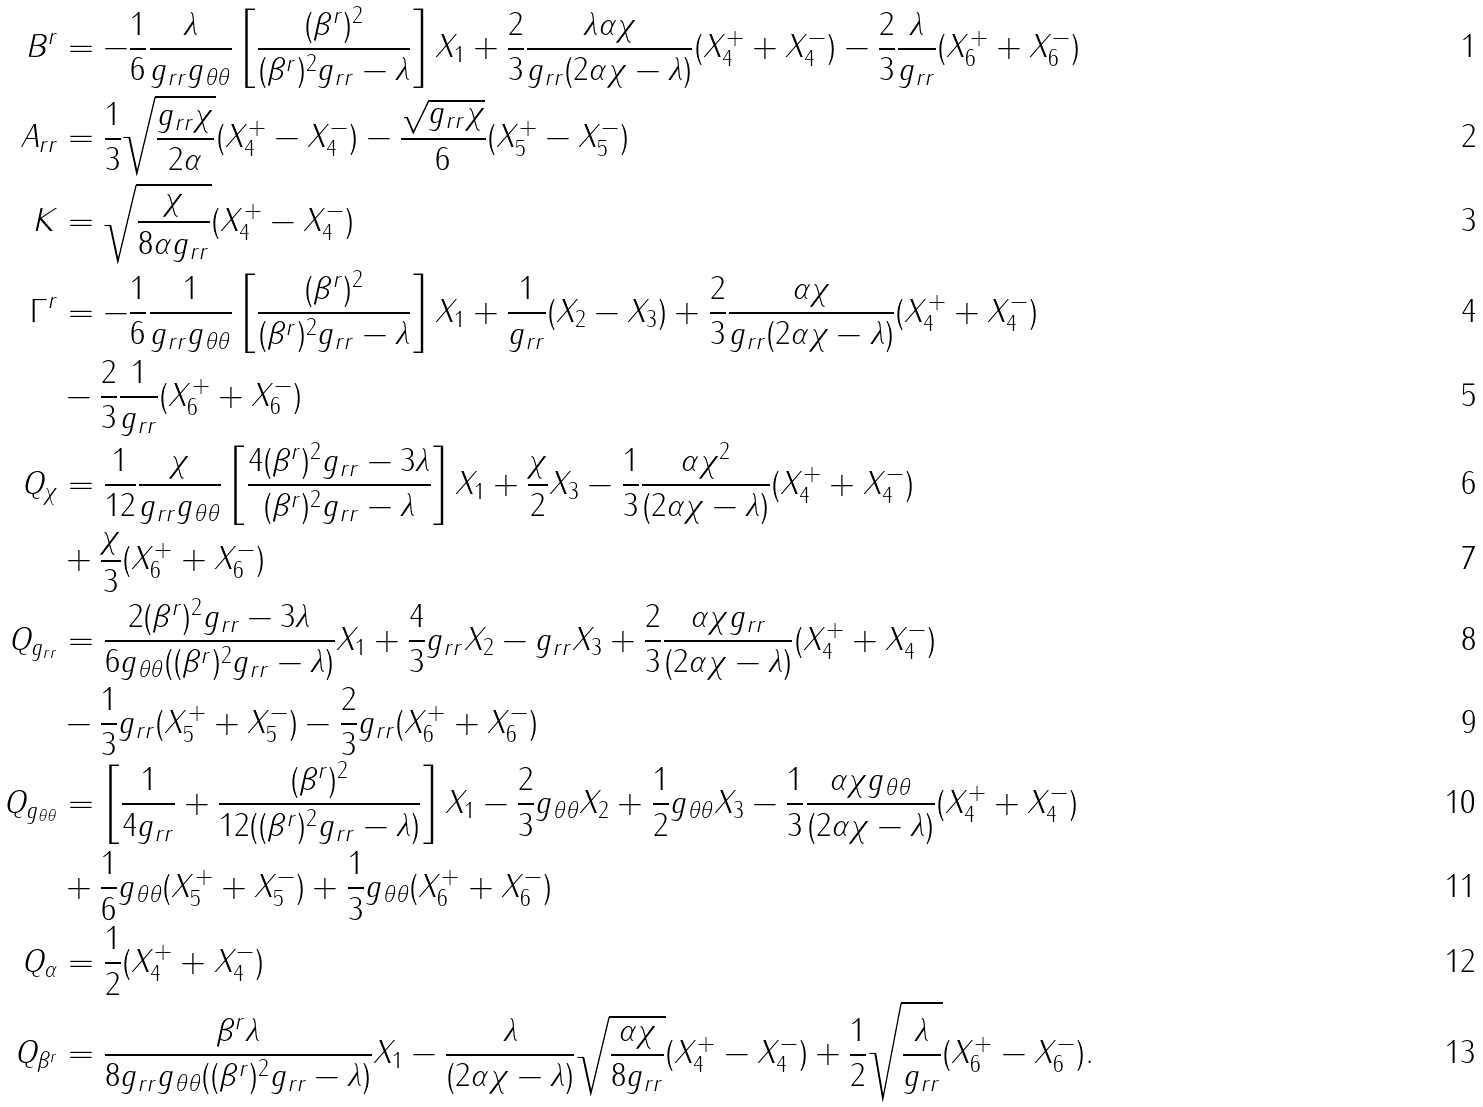Convert formula to latex. <formula><loc_0><loc_0><loc_500><loc_500>B ^ { r } & = - \frac { 1 } { 6 } \frac { \lambda } { g _ { r r } g _ { \theta \theta } } \left [ \frac { ( \beta ^ { r } ) ^ { 2 } } { ( \beta ^ { r } ) ^ { 2 } g _ { r r } - \lambda } \right ] X _ { 1 } + \frac { 2 } { 3 } \frac { \lambda \alpha \chi } { g _ { r r } ( 2 \alpha \chi - \lambda ) } ( X ^ { + } _ { 4 } + X ^ { - } _ { 4 } ) - \frac { 2 } { 3 } \frac { \lambda } { g _ { r r } } ( X ^ { + } _ { 6 } + X ^ { - } _ { 6 } ) \\ A _ { r r } & = \frac { 1 } { 3 } \sqrt { \frac { g _ { r r } \chi } { 2 \alpha } } ( X _ { 4 } ^ { + } - X _ { 4 } ^ { - } ) - \frac { \sqrt { g _ { r r } \chi } } { 6 } ( X _ { 5 } ^ { + } - X _ { 5 } ^ { - } ) \\ K & = \sqrt { \frac { \chi } { 8 \alpha g _ { r r } } } ( X _ { 4 } ^ { + } - X _ { 4 } ^ { - } ) \\ \Gamma ^ { r } & = - \frac { 1 } { 6 } \frac { 1 } { g _ { r r } g _ { \theta \theta } } \left [ \frac { ( \beta ^ { r } ) ^ { 2 } } { ( \beta ^ { r } ) ^ { 2 } g _ { r r } - \lambda } \right ] X _ { 1 } + \frac { 1 } { g _ { r r } } ( X _ { 2 } - X _ { 3 } ) + \frac { 2 } { 3 } \frac { \alpha \chi } { g _ { r r } ( 2 \alpha \chi - \lambda ) } ( X ^ { + } _ { 4 } + X ^ { - } _ { 4 } ) \\ & - \frac { 2 } { 3 } \frac { 1 } { g _ { r r } } ( X ^ { + } _ { 6 } + X ^ { - } _ { 6 } ) \\ Q _ { \chi } & = \frac { 1 } { 1 2 } \frac { \chi } { g _ { r r } g _ { \theta \theta } } \left [ \frac { 4 ( \beta ^ { r } ) ^ { 2 } g _ { r r } - 3 \lambda } { ( \beta ^ { r } ) ^ { 2 } g _ { r r } - \lambda } \right ] X _ { 1 } + \frac { \chi } { 2 } X _ { 3 } - \frac { 1 } { 3 } \frac { \alpha \chi ^ { 2 } } { ( 2 \alpha \chi - \lambda ) } ( X ^ { + } _ { 4 } + X ^ { - } _ { 4 } ) \\ & + \frac { \chi } { 3 } ( X ^ { + } _ { 6 } + X ^ { - } _ { 6 } ) \\ Q _ { g _ { r r } } & = \frac { 2 ( \beta ^ { r } ) ^ { 2 } g _ { r r } - 3 \lambda } { 6 g _ { \theta \theta } ( ( \beta ^ { r } ) ^ { 2 } g _ { r r } - \lambda ) } X _ { 1 } + \frac { 4 } { 3 } g _ { r r } X _ { 2 } - g _ { r r } X _ { 3 } + \frac { 2 } { 3 } \frac { \alpha \chi g _ { r r } } { ( 2 \alpha \chi - \lambda ) } ( X ^ { + } _ { 4 } + X ^ { - } _ { 4 } ) \\ & - \frac { 1 } { 3 } g _ { r r } ( X ^ { + } _ { 5 } + X ^ { - } _ { 5 } ) - \frac { 2 } { 3 } g _ { r r } ( X ^ { + } _ { 6 } + X ^ { - } _ { 6 } ) \\ Q _ { g _ { \theta \theta } } & = \left [ \frac { 1 } { 4 g _ { r r } } + \frac { ( \beta ^ { r } ) ^ { 2 } } { 1 2 ( ( \beta ^ { r } ) ^ { 2 } g _ { r r } - \lambda ) } \right ] X _ { 1 } - \frac { 2 } { 3 } g _ { \theta \theta } X _ { 2 } + \frac { 1 } { 2 } g _ { \theta \theta } X _ { 3 } - \frac { 1 } { 3 } \frac { \alpha \chi g _ { \theta \theta } } { ( 2 \alpha \chi - \lambda ) } ( X ^ { + } _ { 4 } + X ^ { - } _ { 4 } ) \\ & + \frac { 1 } { 6 } g _ { \theta \theta } ( X ^ { + } _ { 5 } + X ^ { - } _ { 5 } ) + \frac { 1 } { 3 } g _ { \theta \theta } ( X ^ { + } _ { 6 } + X ^ { - } _ { 6 } ) \\ Q _ { \alpha } & = \frac { 1 } { 2 } ( X _ { 4 } ^ { + } + X _ { 4 } ^ { - } ) \\ Q _ { \beta ^ { r } } & = \frac { \beta ^ { r } \lambda } { 8 g _ { r r } g _ { \theta \theta } ( ( \beta ^ { r } ) ^ { 2 } g _ { r r } - \lambda ) } X _ { 1 } - \frac { \lambda } { ( 2 \alpha \chi - \lambda ) } \sqrt { \frac { \alpha \chi } { 8 g _ { r r } } } ( X ^ { + } _ { 4 } - X ^ { - } _ { 4 } ) + \frac { 1 } { 2 } \sqrt { \frac { \lambda } { g _ { r r } } } ( X ^ { + } _ { 6 } - X ^ { - } _ { 6 } ) .</formula> 